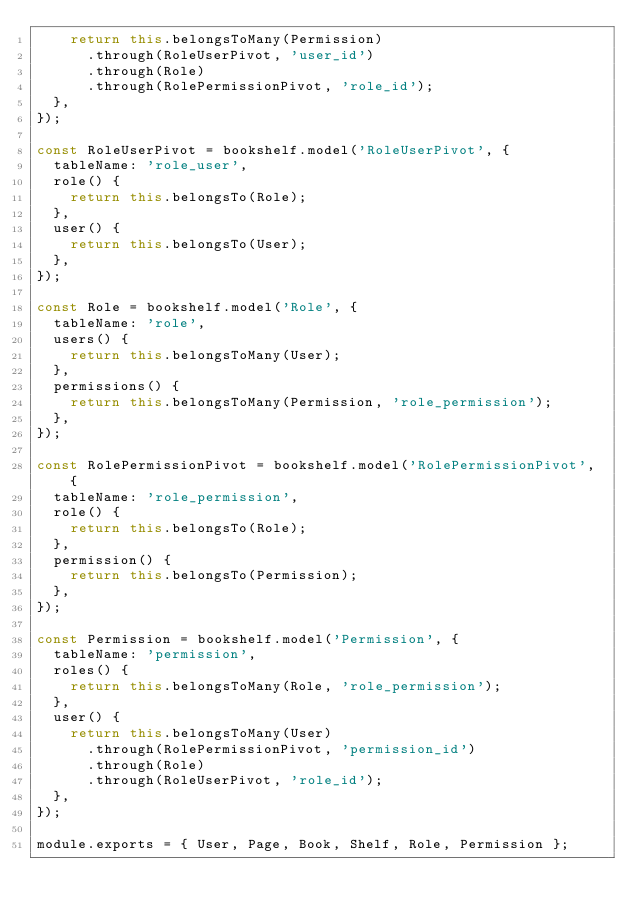Convert code to text. <code><loc_0><loc_0><loc_500><loc_500><_JavaScript_>    return this.belongsToMany(Permission)
      .through(RoleUserPivot, 'user_id')
      .through(Role)
      .through(RolePermissionPivot, 'role_id');
  },
});

const RoleUserPivot = bookshelf.model('RoleUserPivot', {
  tableName: 'role_user',
  role() {
    return this.belongsTo(Role);
  },
  user() {
    return this.belongsTo(User);
  },
});

const Role = bookshelf.model('Role', {
  tableName: 'role',
  users() {
    return this.belongsToMany(User);
  },
  permissions() {
    return this.belongsToMany(Permission, 'role_permission');
  },
});

const RolePermissionPivot = bookshelf.model('RolePermissionPivot', {
  tableName: 'role_permission',
  role() {
    return this.belongsTo(Role);
  },
  permission() {
    return this.belongsTo(Permission);
  },
});

const Permission = bookshelf.model('Permission', {
  tableName: 'permission',
  roles() {
    return this.belongsToMany(Role, 'role_permission');
  },
  user() {
    return this.belongsToMany(User)
      .through(RolePermissionPivot, 'permission_id')
      .through(Role)
      .through(RoleUserPivot, 'role_id');
  },
});

module.exports = { User, Page, Book, Shelf, Role, Permission };
</code> 